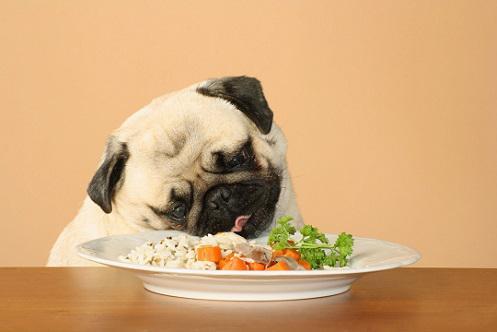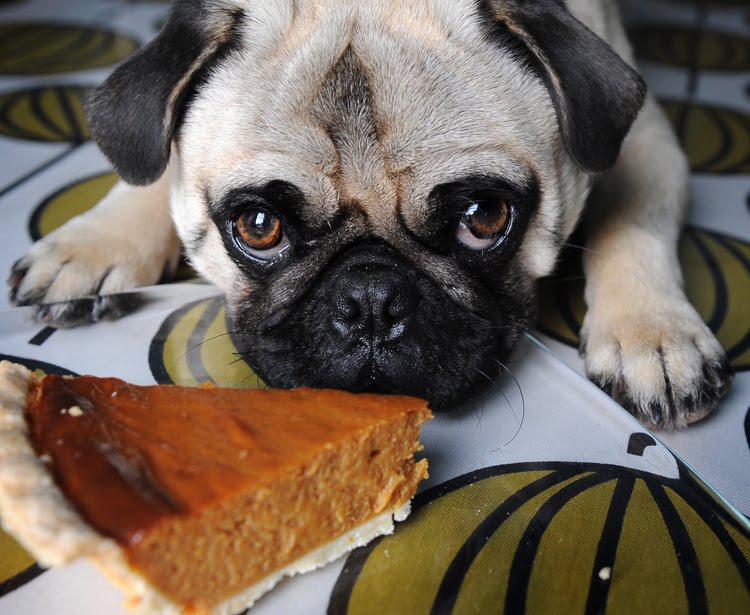The first image is the image on the left, the second image is the image on the right. For the images displayed, is the sentence "The dog in the image on the left is sitting before a white plate of food." factually correct? Answer yes or no. Yes. 